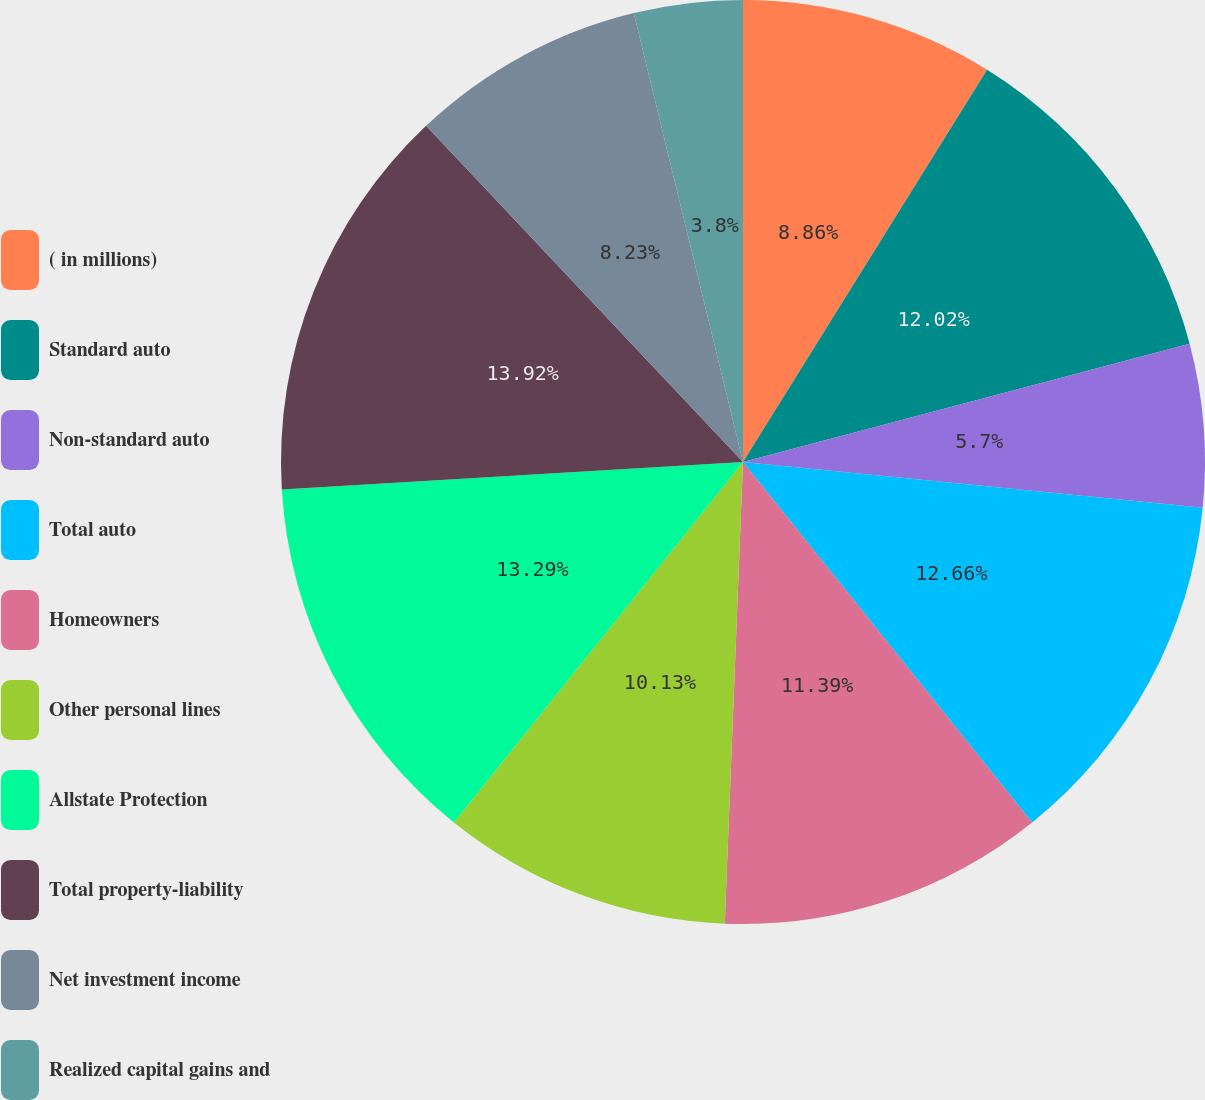Convert chart. <chart><loc_0><loc_0><loc_500><loc_500><pie_chart><fcel>( in millions)<fcel>Standard auto<fcel>Non-standard auto<fcel>Total auto<fcel>Homeowners<fcel>Other personal lines<fcel>Allstate Protection<fcel>Total property-liability<fcel>Net investment income<fcel>Realized capital gains and<nl><fcel>8.86%<fcel>12.02%<fcel>5.7%<fcel>12.66%<fcel>11.39%<fcel>10.13%<fcel>13.29%<fcel>13.92%<fcel>8.23%<fcel>3.8%<nl></chart> 